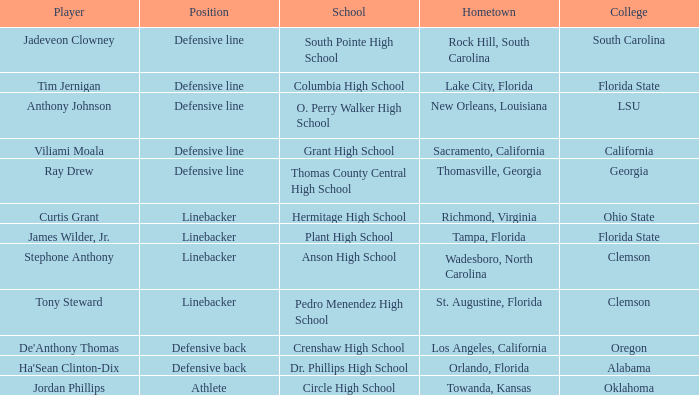Which player is from Tampa, Florida? James Wilder, Jr. 